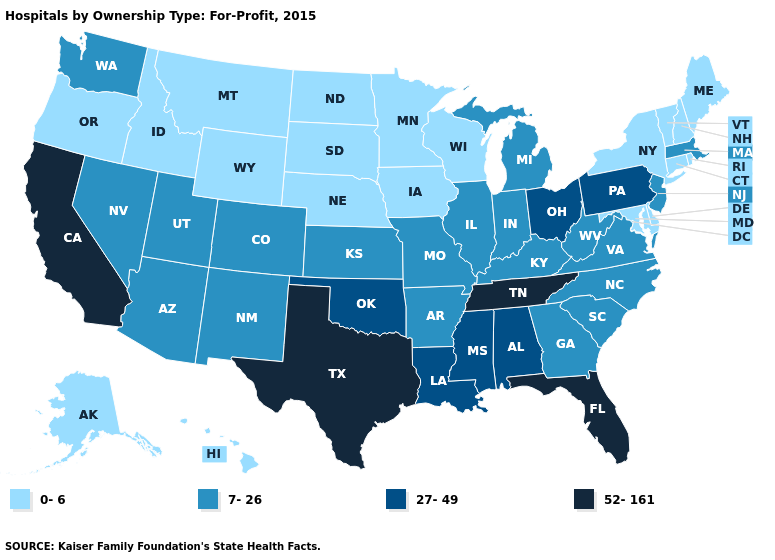Name the states that have a value in the range 27-49?
Keep it brief. Alabama, Louisiana, Mississippi, Ohio, Oklahoma, Pennsylvania. Which states have the lowest value in the USA?
Short answer required. Alaska, Connecticut, Delaware, Hawaii, Idaho, Iowa, Maine, Maryland, Minnesota, Montana, Nebraska, New Hampshire, New York, North Dakota, Oregon, Rhode Island, South Dakota, Vermont, Wisconsin, Wyoming. What is the value of Arizona?
Be succinct. 7-26. What is the value of Vermont?
Be succinct. 0-6. Does Idaho have the highest value in the West?
Concise answer only. No. What is the value of Iowa?
Keep it brief. 0-6. Does the map have missing data?
Short answer required. No. What is the highest value in the USA?
Write a very short answer. 52-161. What is the lowest value in the USA?
Write a very short answer. 0-6. Which states hav the highest value in the Northeast?
Quick response, please. Pennsylvania. Name the states that have a value in the range 0-6?
Quick response, please. Alaska, Connecticut, Delaware, Hawaii, Idaho, Iowa, Maine, Maryland, Minnesota, Montana, Nebraska, New Hampshire, New York, North Dakota, Oregon, Rhode Island, South Dakota, Vermont, Wisconsin, Wyoming. How many symbols are there in the legend?
Concise answer only. 4. What is the lowest value in the West?
Answer briefly. 0-6. 